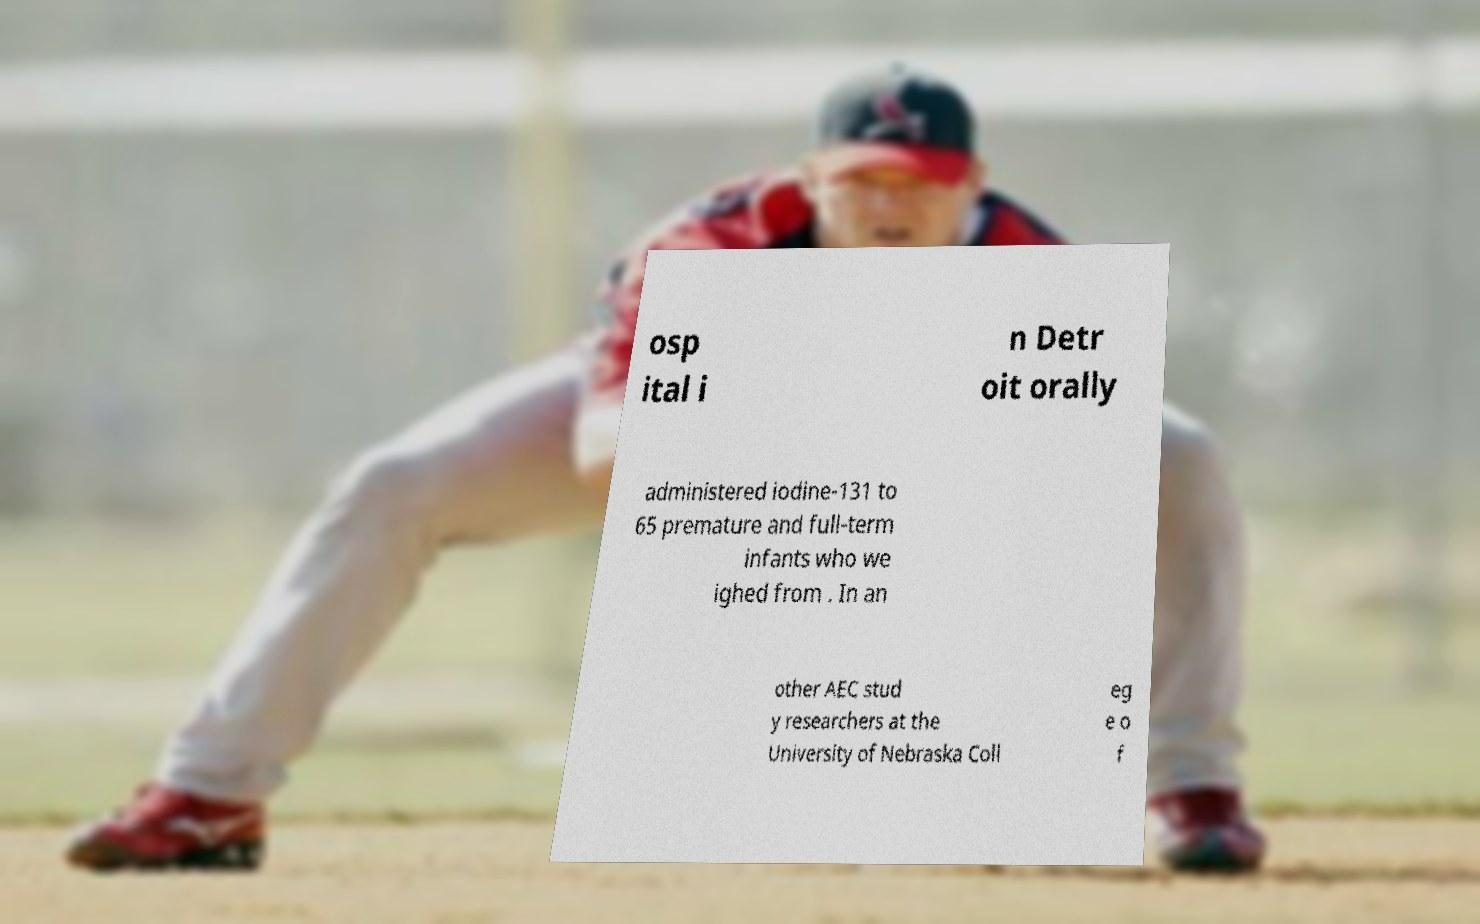I need the written content from this picture converted into text. Can you do that? osp ital i n Detr oit orally administered iodine-131 to 65 premature and full-term infants who we ighed from . In an other AEC stud y researchers at the University of Nebraska Coll eg e o f 